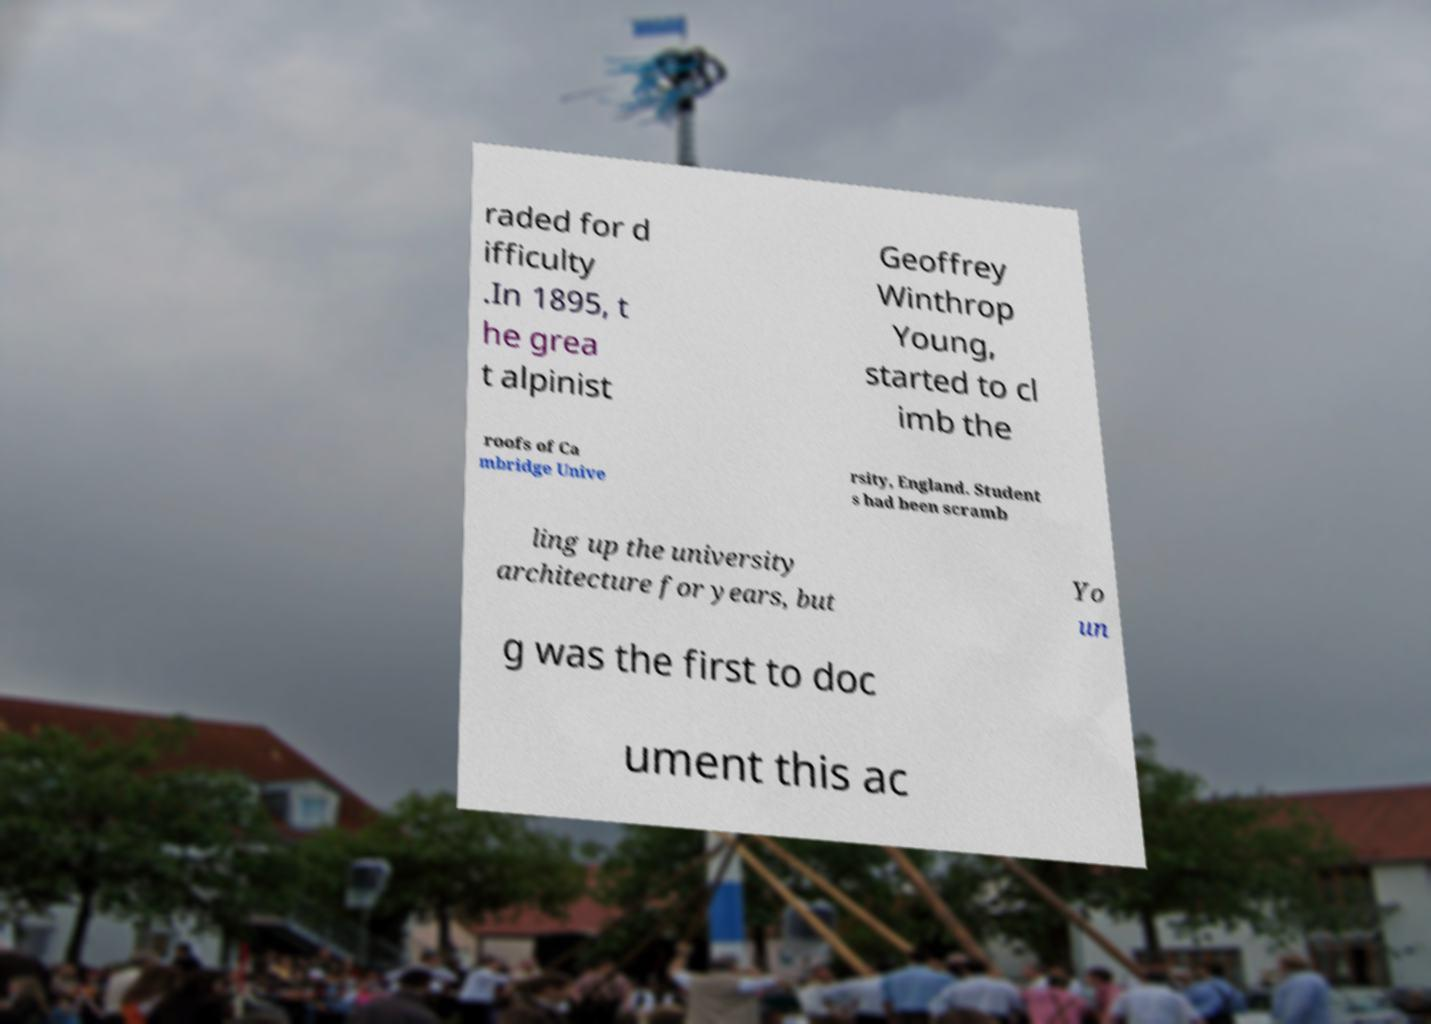Can you read and provide the text displayed in the image?This photo seems to have some interesting text. Can you extract and type it out for me? raded for d ifficulty .In 1895, t he grea t alpinist Geoffrey Winthrop Young, started to cl imb the roofs of Ca mbridge Unive rsity, England. Student s had been scramb ling up the university architecture for years, but Yo un g was the first to doc ument this ac 